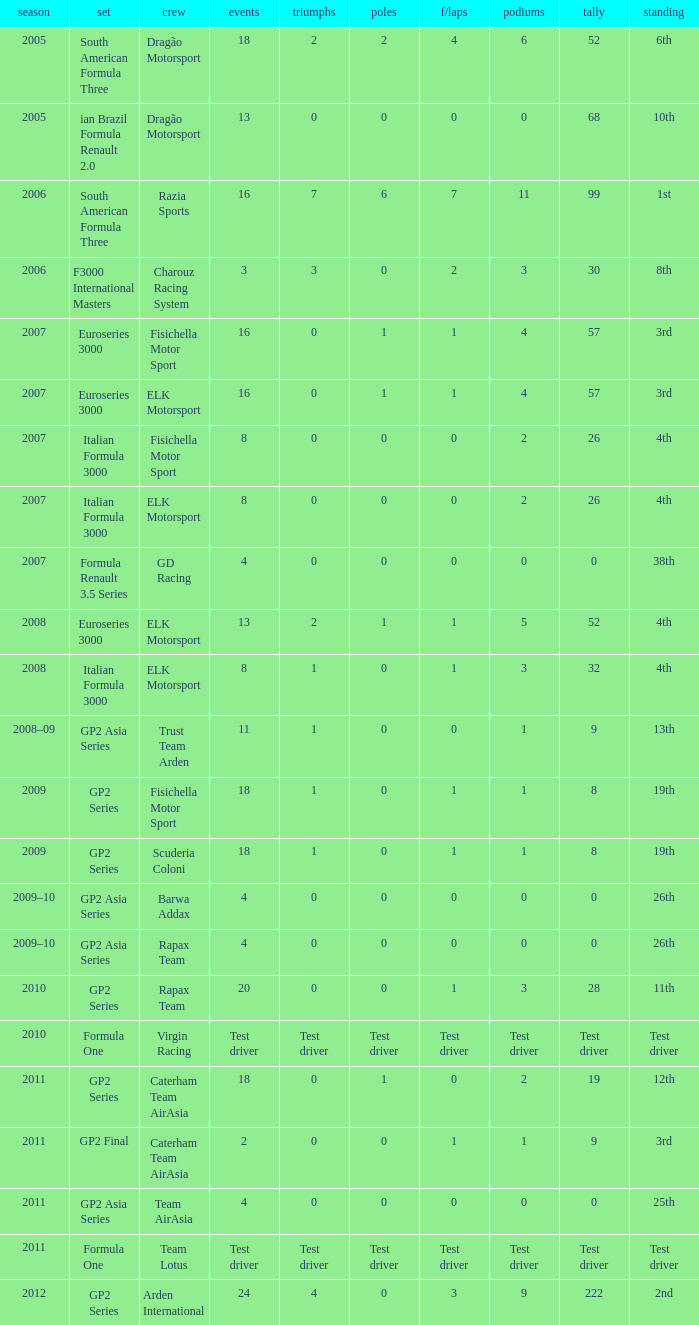What were the points in the year when his Podiums were 5? 52.0. 